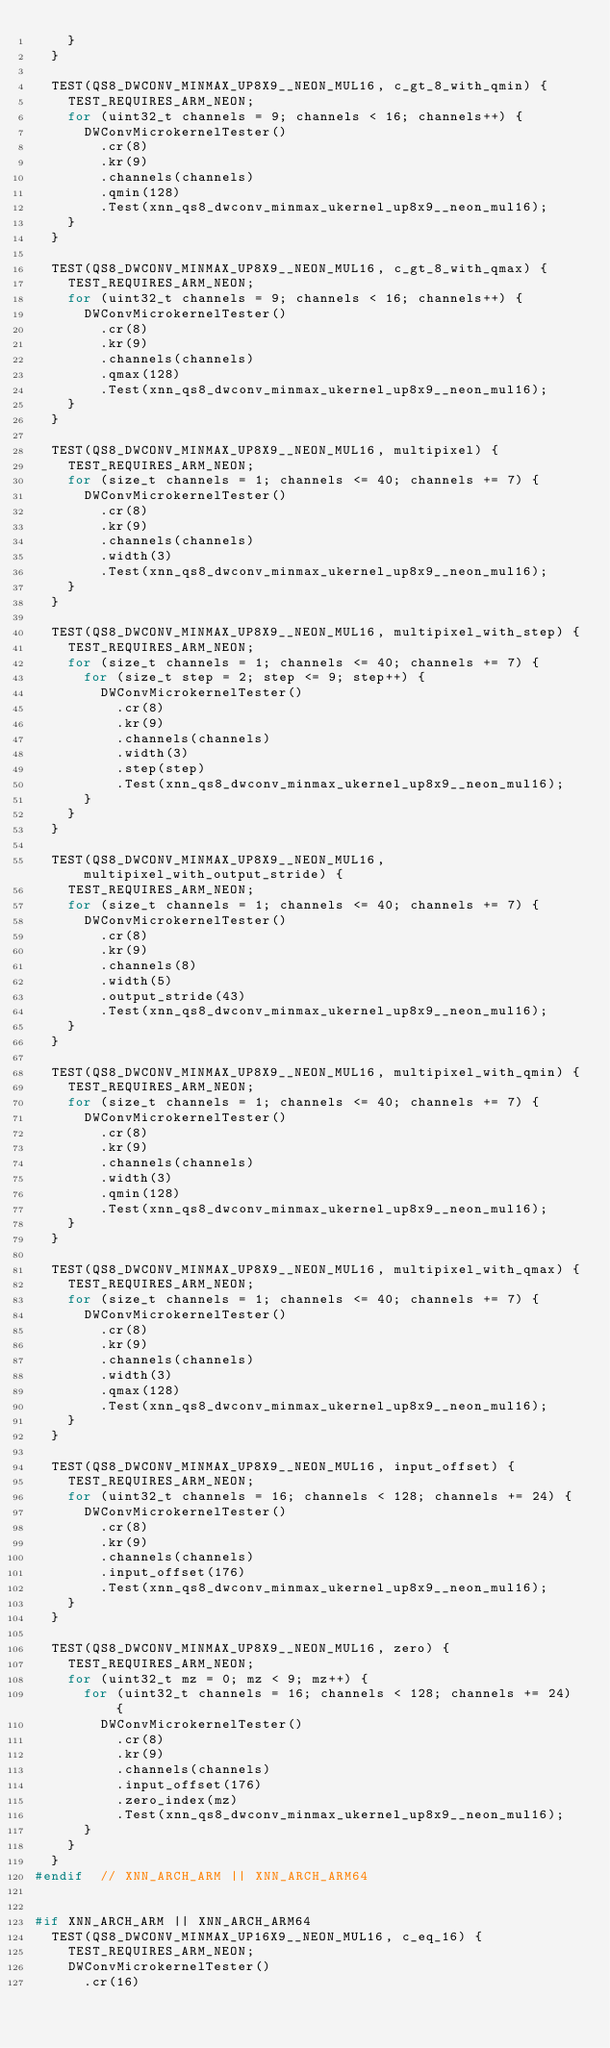<code> <loc_0><loc_0><loc_500><loc_500><_C++_>    }
  }

  TEST(QS8_DWCONV_MINMAX_UP8X9__NEON_MUL16, c_gt_8_with_qmin) {
    TEST_REQUIRES_ARM_NEON;
    for (uint32_t channels = 9; channels < 16; channels++) {
      DWConvMicrokernelTester()
        .cr(8)
        .kr(9)
        .channels(channels)
        .qmin(128)
        .Test(xnn_qs8_dwconv_minmax_ukernel_up8x9__neon_mul16);
    }
  }

  TEST(QS8_DWCONV_MINMAX_UP8X9__NEON_MUL16, c_gt_8_with_qmax) {
    TEST_REQUIRES_ARM_NEON;
    for (uint32_t channels = 9; channels < 16; channels++) {
      DWConvMicrokernelTester()
        .cr(8)
        .kr(9)
        .channels(channels)
        .qmax(128)
        .Test(xnn_qs8_dwconv_minmax_ukernel_up8x9__neon_mul16);
    }
  }

  TEST(QS8_DWCONV_MINMAX_UP8X9__NEON_MUL16, multipixel) {
    TEST_REQUIRES_ARM_NEON;
    for (size_t channels = 1; channels <= 40; channels += 7) {
      DWConvMicrokernelTester()
        .cr(8)
        .kr(9)
        .channels(channels)
        .width(3)
        .Test(xnn_qs8_dwconv_minmax_ukernel_up8x9__neon_mul16);
    }
  }

  TEST(QS8_DWCONV_MINMAX_UP8X9__NEON_MUL16, multipixel_with_step) {
    TEST_REQUIRES_ARM_NEON;
    for (size_t channels = 1; channels <= 40; channels += 7) {
      for (size_t step = 2; step <= 9; step++) {
        DWConvMicrokernelTester()
          .cr(8)
          .kr(9)
          .channels(channels)
          .width(3)
          .step(step)
          .Test(xnn_qs8_dwconv_minmax_ukernel_up8x9__neon_mul16);
      }
    }
  }

  TEST(QS8_DWCONV_MINMAX_UP8X9__NEON_MUL16, multipixel_with_output_stride) {
    TEST_REQUIRES_ARM_NEON;
    for (size_t channels = 1; channels <= 40; channels += 7) {
      DWConvMicrokernelTester()
        .cr(8)
        .kr(9)
        .channels(8)
        .width(5)
        .output_stride(43)
        .Test(xnn_qs8_dwconv_minmax_ukernel_up8x9__neon_mul16);
    }
  }

  TEST(QS8_DWCONV_MINMAX_UP8X9__NEON_MUL16, multipixel_with_qmin) {
    TEST_REQUIRES_ARM_NEON;
    for (size_t channels = 1; channels <= 40; channels += 7) {
      DWConvMicrokernelTester()
        .cr(8)
        .kr(9)
        .channels(channels)
        .width(3)
        .qmin(128)
        .Test(xnn_qs8_dwconv_minmax_ukernel_up8x9__neon_mul16);
    }
  }

  TEST(QS8_DWCONV_MINMAX_UP8X9__NEON_MUL16, multipixel_with_qmax) {
    TEST_REQUIRES_ARM_NEON;
    for (size_t channels = 1; channels <= 40; channels += 7) {
      DWConvMicrokernelTester()
        .cr(8)
        .kr(9)
        .channels(channels)
        .width(3)
        .qmax(128)
        .Test(xnn_qs8_dwconv_minmax_ukernel_up8x9__neon_mul16);
    }
  }

  TEST(QS8_DWCONV_MINMAX_UP8X9__NEON_MUL16, input_offset) {
    TEST_REQUIRES_ARM_NEON;
    for (uint32_t channels = 16; channels < 128; channels += 24) {
      DWConvMicrokernelTester()
        .cr(8)
        .kr(9)
        .channels(channels)
        .input_offset(176)
        .Test(xnn_qs8_dwconv_minmax_ukernel_up8x9__neon_mul16);
    }
  }

  TEST(QS8_DWCONV_MINMAX_UP8X9__NEON_MUL16, zero) {
    TEST_REQUIRES_ARM_NEON;
    for (uint32_t mz = 0; mz < 9; mz++) {
      for (uint32_t channels = 16; channels < 128; channels += 24) {
        DWConvMicrokernelTester()
          .cr(8)
          .kr(9)
          .channels(channels)
          .input_offset(176)
          .zero_index(mz)
          .Test(xnn_qs8_dwconv_minmax_ukernel_up8x9__neon_mul16);
      }
    }
  }
#endif  // XNN_ARCH_ARM || XNN_ARCH_ARM64


#if XNN_ARCH_ARM || XNN_ARCH_ARM64
  TEST(QS8_DWCONV_MINMAX_UP16X9__NEON_MUL16, c_eq_16) {
    TEST_REQUIRES_ARM_NEON;
    DWConvMicrokernelTester()
      .cr(16)</code> 